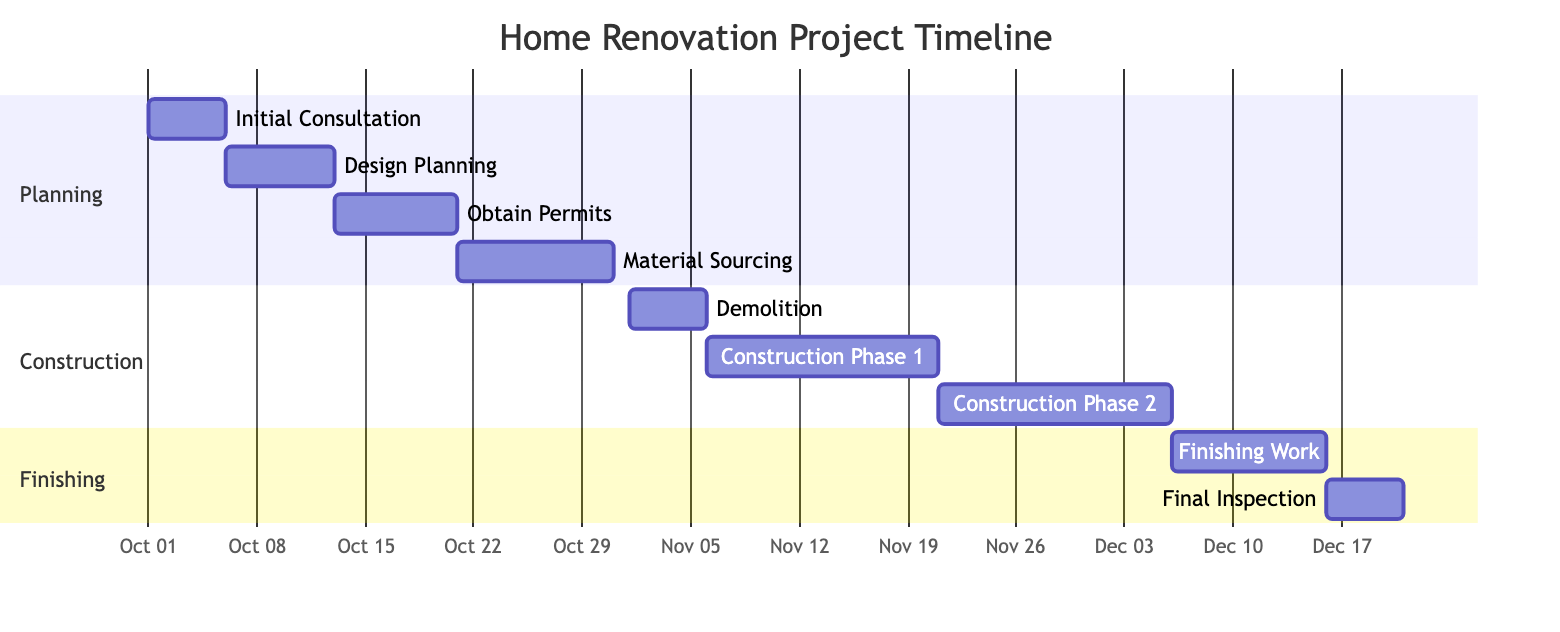What is the duration of the "Design Planning" task? The "Design Planning" task starts on October 6, 2023, and ends on October 12, 2023. This gives a duration of 7 days.
Answer: 7 days When does the "Material Sourcing" task begin? The "Material Sourcing" task starts immediately after the "Obtain Permits" task, which ends on October 20, 2023. Therefore, "Material Sourcing" begins on October 21, 2023.
Answer: October 21, 2023 How many construction phases are listed in the chart? The chart includes two construction phases: "Construction Phase 1" and "Construction Phase 2." Thus, the total count is 2.
Answer: 2 What is the end date of the "Final Inspection"? The "Final Inspection" task starts on December 16, 2023, and lasts for 5 days, ending on December 20, 2023.
Answer: December 20, 2023 Which task occurs directly after "Demolition"? The task "Construction Phase 1" follows directly after the "Demolition" task that ends on November 5, 2023.
Answer: Construction Phase 1 What is the total duration of the "Construction" section? The "Construction" section consists of three tasks: "Demolition" (5 days), "Construction Phase 1" (15 days), and "Construction Phase 2" (15 days). Adding these durations gives a total of 35 days.
Answer: 35 days Which task has the longest duration? Among all tasks, "Construction Phase 1" and "Construction Phase 2" both last for 15 days, which is the longest duration among the tasks listed.
Answer: Construction Phase 1 and Construction Phase 2 What is the sequence of tasks before the "Finishing Work"? Before "Finishing Work," the tasks are "Material Sourcing," "Demolition," and both "Construction Phases." The sequence is: Material Sourcing → Demolition → Construction Phase 1 → Construction Phase 2.
Answer: Material Sourcing, Demolition, Construction Phase 1, Construction Phase 2 In which section is the "Initial Consultation" task located? The "Initial Consultation" task is part of the "Planning" section, which consists of initial tasks related to preparing the project.
Answer: Planning 